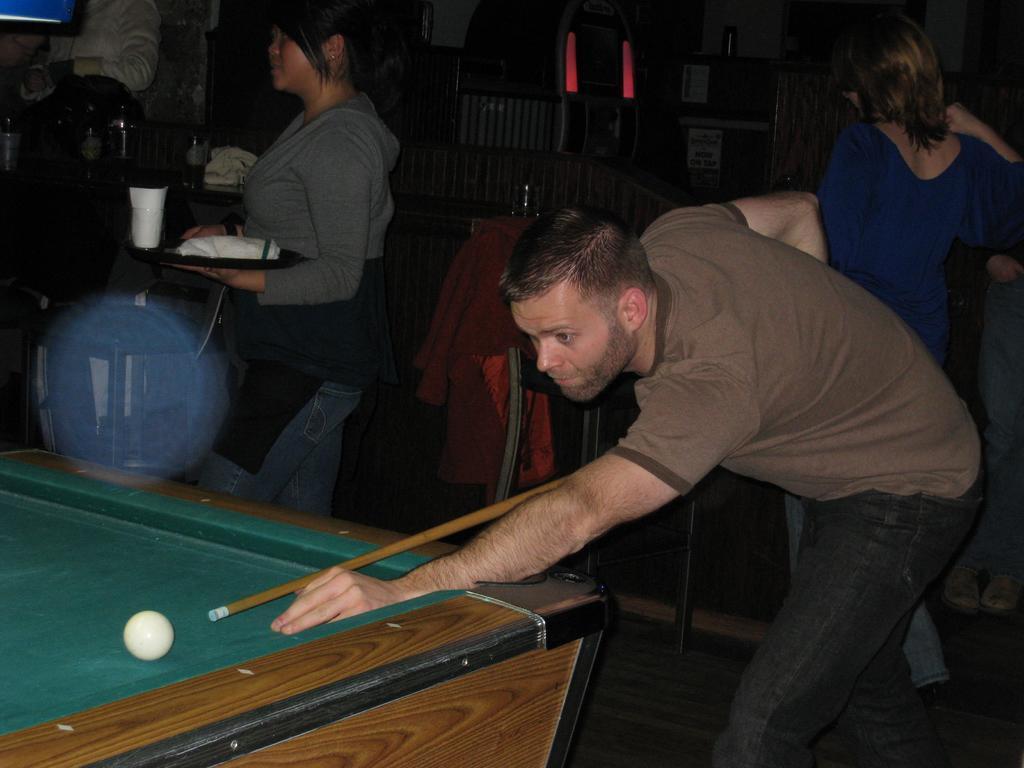Please provide a concise description of this image. A person holding billiard stick and playing billiards. In front of him there is a table and a board. Behind him some persons are standing. A lady is holding a tray with bottle, glass and some items. Also there is a chair with a jacket in the background. 